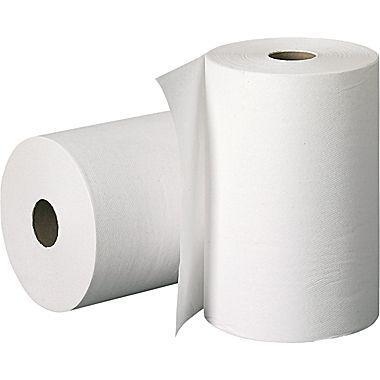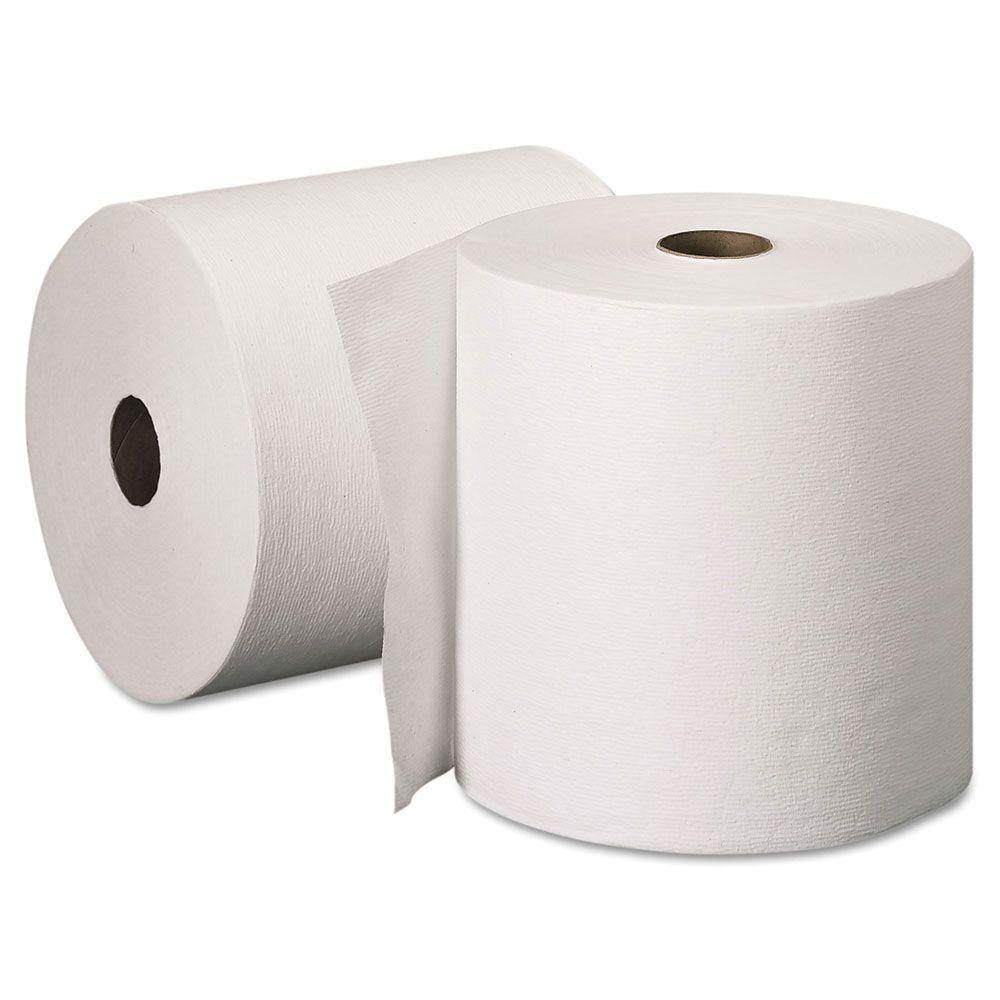The first image is the image on the left, the second image is the image on the right. Analyze the images presented: Is the assertion "All paper towels are white and on rolls." valid? Answer yes or no. Yes. The first image is the image on the left, the second image is the image on the right. For the images shown, is this caption "An image shows only flat, folded paper towels." true? Answer yes or no. No. 